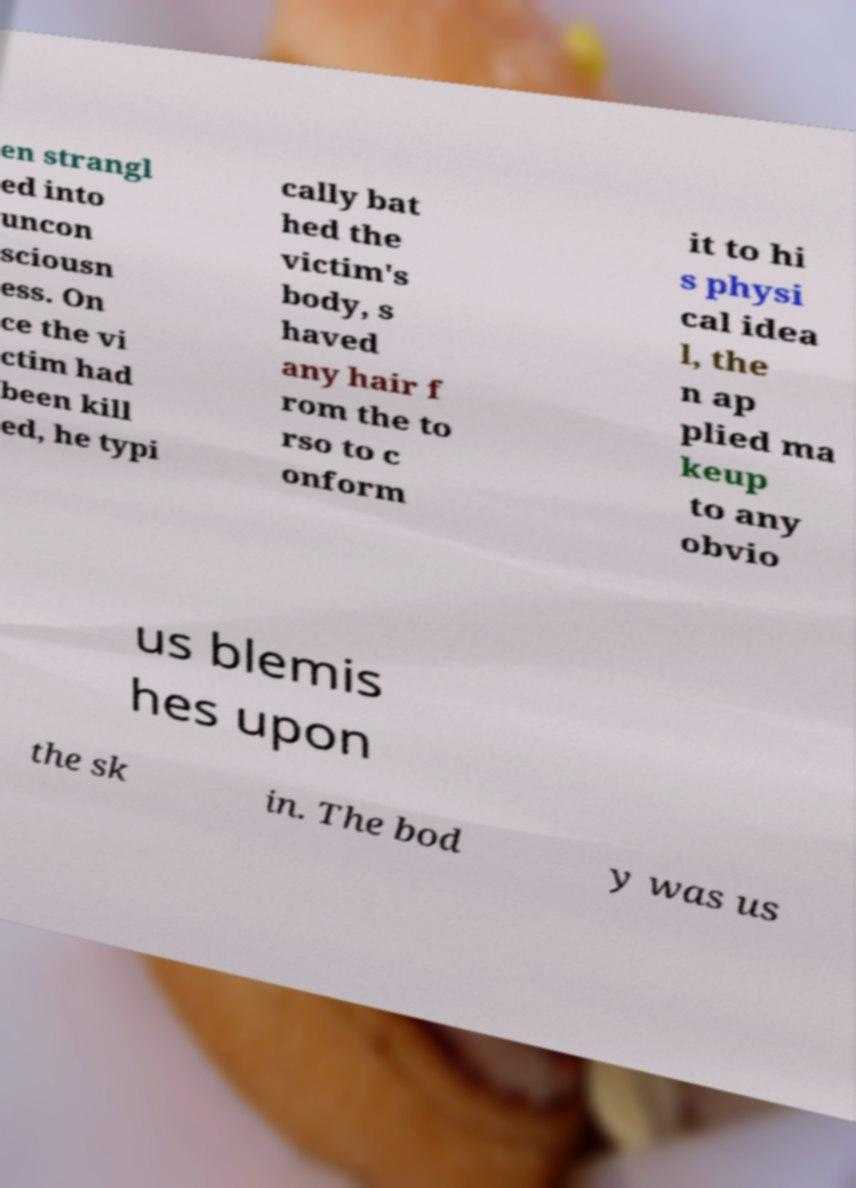I need the written content from this picture converted into text. Can you do that? en strangl ed into uncon sciousn ess. On ce the vi ctim had been kill ed, he typi cally bat hed the victim's body, s haved any hair f rom the to rso to c onform it to hi s physi cal idea l, the n ap plied ma keup to any obvio us blemis hes upon the sk in. The bod y was us 